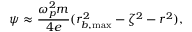Convert formula to latex. <formula><loc_0><loc_0><loc_500><loc_500>\psi \approx \frac { \omega _ { p } ^ { 2 } m } { 4 e } ( r _ { b , \max } ^ { 2 } - \zeta ^ { 2 } - r ^ { 2 } ) ,</formula> 